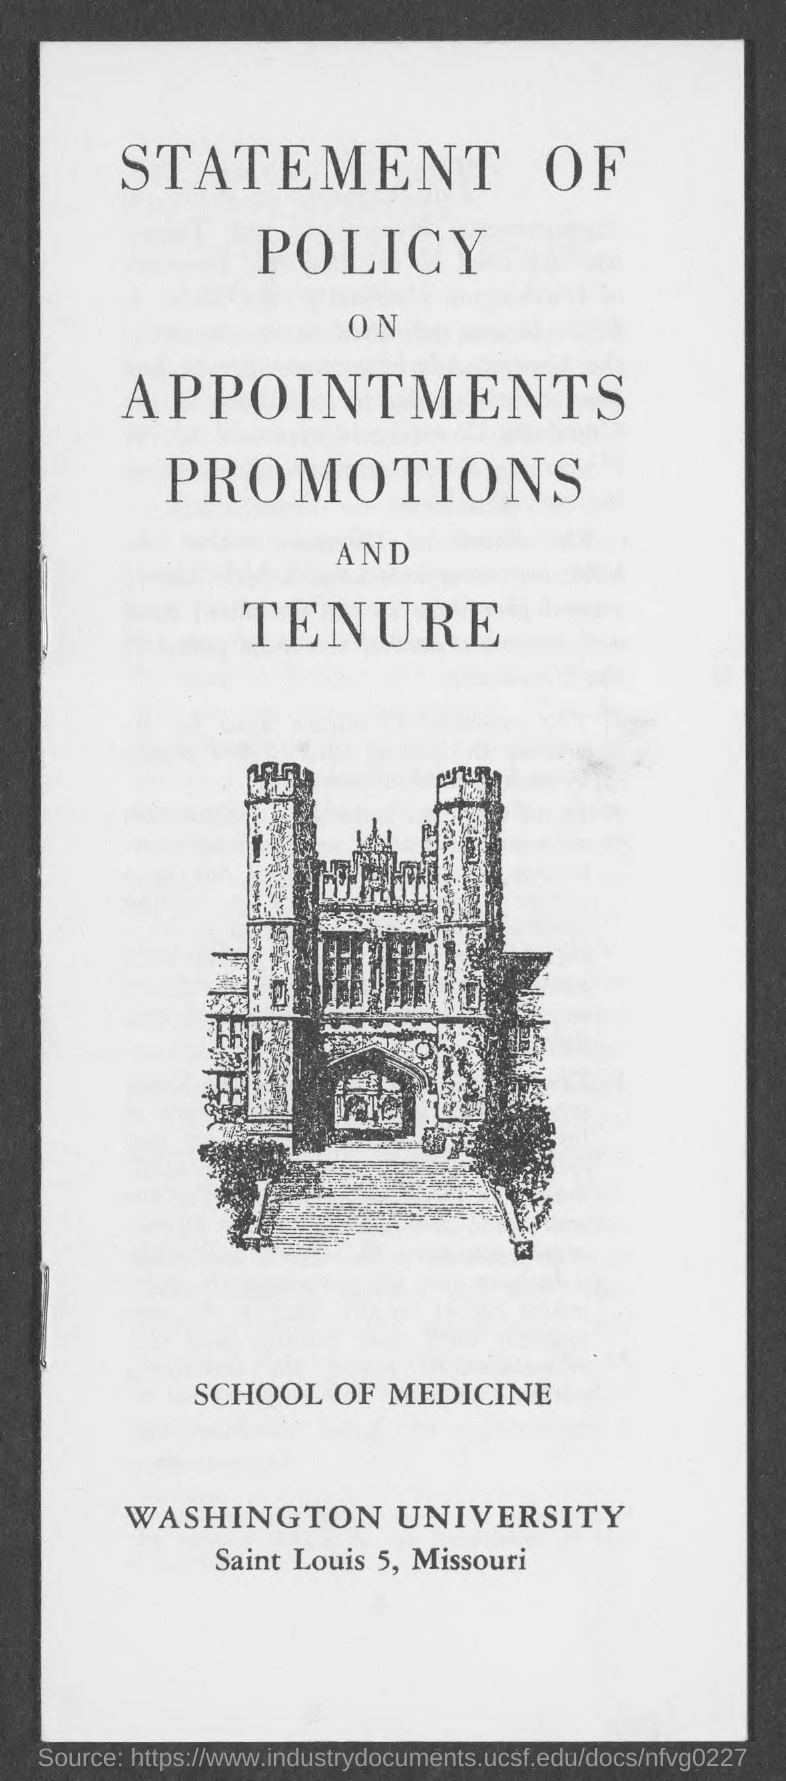Draw attention to some important aspects in this diagram. The university mentioned in the document is Washington University. 